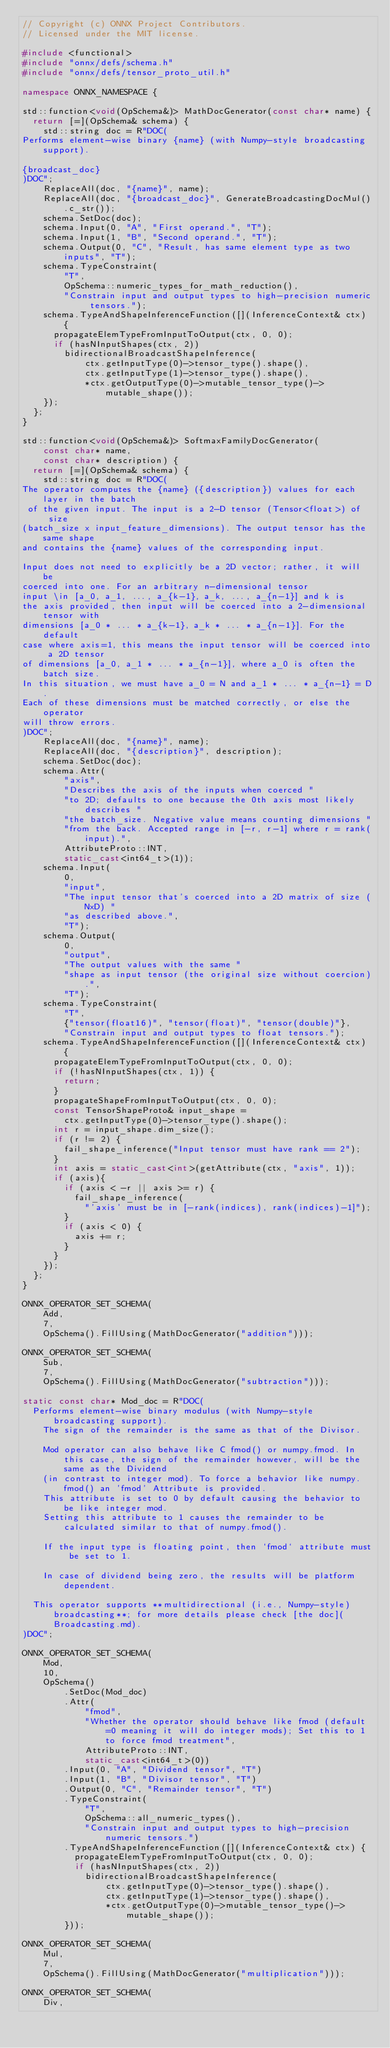<code> <loc_0><loc_0><loc_500><loc_500><_C++_>// Copyright (c) ONNX Project Contributors.
// Licensed under the MIT license.

#include <functional>
#include "onnx/defs/schema.h"
#include "onnx/defs/tensor_proto_util.h"

namespace ONNX_NAMESPACE {

std::function<void(OpSchema&)> MathDocGenerator(const char* name) {
  return [=](OpSchema& schema) {
    std::string doc = R"DOC(
Performs element-wise binary {name} (with Numpy-style broadcasting support).

{broadcast_doc}
)DOC";
    ReplaceAll(doc, "{name}", name);
    ReplaceAll(doc, "{broadcast_doc}", GenerateBroadcastingDocMul().c_str());
    schema.SetDoc(doc);
    schema.Input(0, "A", "First operand.", "T");
    schema.Input(1, "B", "Second operand.", "T");
    schema.Output(0, "C", "Result, has same element type as two inputs", "T");
    schema.TypeConstraint(
        "T",
        OpSchema::numeric_types_for_math_reduction(),
        "Constrain input and output types to high-precision numeric tensors.");
    schema.TypeAndShapeInferenceFunction([](InferenceContext& ctx) {
      propagateElemTypeFromInputToOutput(ctx, 0, 0);
      if (hasNInputShapes(ctx, 2))
        bidirectionalBroadcastShapeInference(
            ctx.getInputType(0)->tensor_type().shape(),
            ctx.getInputType(1)->tensor_type().shape(),
            *ctx.getOutputType(0)->mutable_tensor_type()->mutable_shape());
    });
  };
}

std::function<void(OpSchema&)> SoftmaxFamilyDocGenerator(
    const char* name,
    const char* description) {
  return [=](OpSchema& schema) {
    std::string doc = R"DOC(
The operator computes the {name} ({description}) values for each layer in the batch
 of the given input. The input is a 2-D tensor (Tensor<float>) of size
(batch_size x input_feature_dimensions). The output tensor has the same shape
and contains the {name} values of the corresponding input.

Input does not need to explicitly be a 2D vector; rather, it will be
coerced into one. For an arbitrary n-dimensional tensor
input \in [a_0, a_1, ..., a_{k-1}, a_k, ..., a_{n-1}] and k is
the axis provided, then input will be coerced into a 2-dimensional tensor with
dimensions [a_0 * ... * a_{k-1}, a_k * ... * a_{n-1}]. For the default
case where axis=1, this means the input tensor will be coerced into a 2D tensor
of dimensions [a_0, a_1 * ... * a_{n-1}], where a_0 is often the batch size.
In this situation, we must have a_0 = N and a_1 * ... * a_{n-1} = D.
Each of these dimensions must be matched correctly, or else the operator
will throw errors.
)DOC";
    ReplaceAll(doc, "{name}", name);
    ReplaceAll(doc, "{description}", description);
    schema.SetDoc(doc);
    schema.Attr(
        "axis",
        "Describes the axis of the inputs when coerced "
        "to 2D; defaults to one because the 0th axis most likely describes "
        "the batch_size. Negative value means counting dimensions "
        "from the back. Accepted range in [-r, r-1] where r = rank(input).",
        AttributeProto::INT,
        static_cast<int64_t>(1));
    schema.Input(
        0,
        "input",
        "The input tensor that's coerced into a 2D matrix of size (NxD) "
        "as described above.",
        "T");
    schema.Output(
        0,
        "output",
        "The output values with the same "
        "shape as input tensor (the original size without coercion).",
        "T");
    schema.TypeConstraint(
        "T",
        {"tensor(float16)", "tensor(float)", "tensor(double)"},
        "Constrain input and output types to float tensors.");
    schema.TypeAndShapeInferenceFunction([](InferenceContext& ctx) {
      propagateElemTypeFromInputToOutput(ctx, 0, 0);
      if (!hasNInputShapes(ctx, 1)) {
        return;
      }
      propagateShapeFromInputToOutput(ctx, 0, 0);
      const TensorShapeProto& input_shape =
        ctx.getInputType(0)->tensor_type().shape();
      int r = input_shape.dim_size();
      if (r != 2) {
        fail_shape_inference("Input tensor must have rank == 2");
      }
      int axis = static_cast<int>(getAttribute(ctx, "axis", 1));
      if (axis){
        if (axis < -r || axis >= r) {
          fail_shape_inference(
            "'axis' must be in [-rank(indices), rank(indices)-1]");
        }
        if (axis < 0) {
          axis += r;
        }
      }
    });
  };
}

ONNX_OPERATOR_SET_SCHEMA(
    Add,
    7,
    OpSchema().FillUsing(MathDocGenerator("addition")));

ONNX_OPERATOR_SET_SCHEMA(
    Sub,
    7,
    OpSchema().FillUsing(MathDocGenerator("subtraction")));

static const char* Mod_doc = R"DOC(
  Performs element-wise binary modulus (with Numpy-style broadcasting support). 
    The sign of the remainder is the same as that of the Divisor.
  
    Mod operator can also behave like C fmod() or numpy.fmod. In this case, the sign of the remainder however, will be the same as the Dividend 
    (in contrast to integer mod). To force a behavior like numpy.fmod() an 'fmod' Attribute is provided.
    This attribute is set to 0 by default causing the behavior to be like integer mod. 
    Setting this attribute to 1 causes the remainder to be calculated similar to that of numpy.fmod().

    If the input type is floating point, then `fmod` attribute must be set to 1.
  
    In case of dividend being zero, the results will be platform dependent.

  This operator supports **multidirectional (i.e., Numpy-style) broadcasting**; for more details please check [the doc](Broadcasting.md).
)DOC";

ONNX_OPERATOR_SET_SCHEMA(
    Mod,
    10,
    OpSchema()
        .SetDoc(Mod_doc)
        .Attr(
            "fmod",
            "Whether the operator should behave like fmod (default=0 meaning it will do integer mods); Set this to 1 to force fmod treatment",
            AttributeProto::INT,
            static_cast<int64_t>(0))
        .Input(0, "A", "Dividend tensor", "T")
        .Input(1, "B", "Divisor tensor", "T")
        .Output(0, "C", "Remainder tensor", "T")
        .TypeConstraint(
            "T",
            OpSchema::all_numeric_types(),
            "Constrain input and output types to high-precision numeric tensors.")
        .TypeAndShapeInferenceFunction([](InferenceContext& ctx) {
          propagateElemTypeFromInputToOutput(ctx, 0, 0);
          if (hasNInputShapes(ctx, 2))
            bidirectionalBroadcastShapeInference(
                ctx.getInputType(0)->tensor_type().shape(),
                ctx.getInputType(1)->tensor_type().shape(),
                *ctx.getOutputType(0)->mutable_tensor_type()->mutable_shape());
        }));

ONNX_OPERATOR_SET_SCHEMA(
    Mul,
    7,
    OpSchema().FillUsing(MathDocGenerator("multiplication")));

ONNX_OPERATOR_SET_SCHEMA(
    Div,</code> 